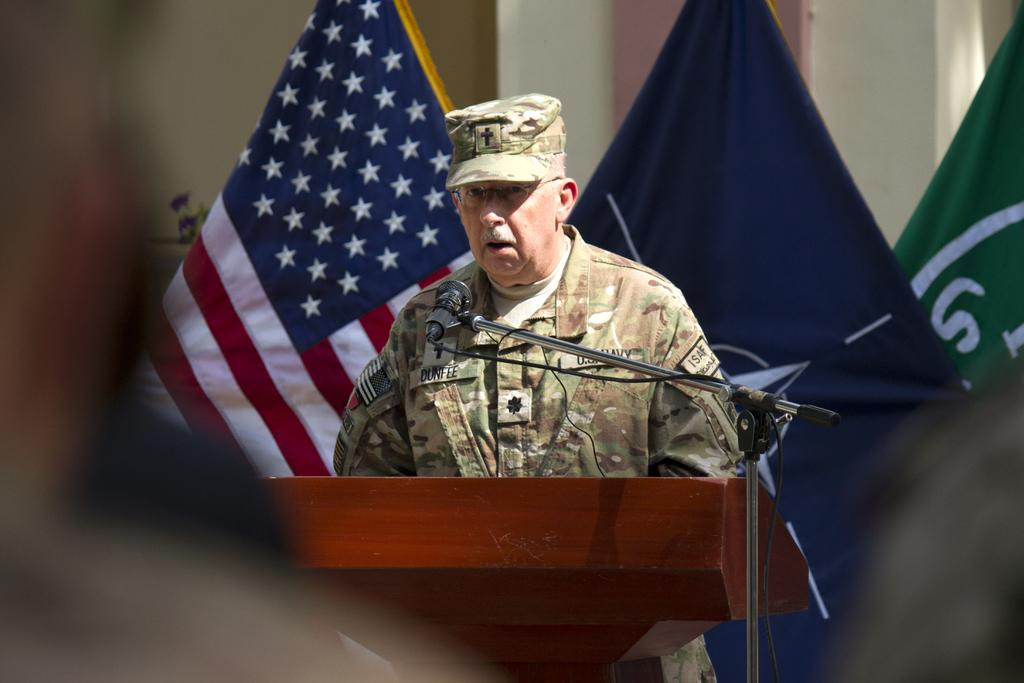What is the man in the image doing? The man is standing in the center of the image. What is in front of the man? There is a podium in front of the man. What is on the podium? A microphone is placed on a stand on the podium. What can be seen in the background of the image? There are flags and a wall in the background of the image. What type of play is being performed in the image? There is no play being performed in the image; it shows a man standing near a podium with a microphone. What is the topic of the discussion taking place in the image? There is no discussion taking place in the image; it only shows a man standing near a podium with a microphone. 